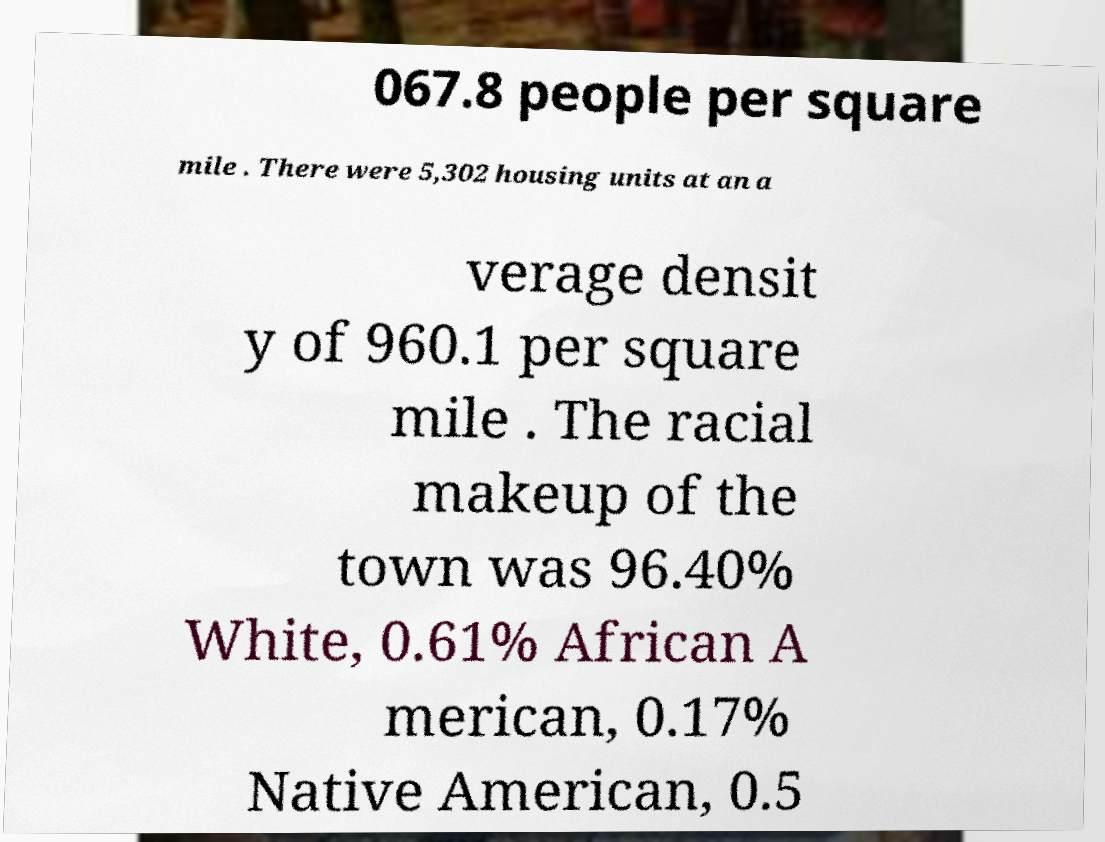There's text embedded in this image that I need extracted. Can you transcribe it verbatim? 067.8 people per square mile . There were 5,302 housing units at an a verage densit y of 960.1 per square mile . The racial makeup of the town was 96.40% White, 0.61% African A merican, 0.17% Native American, 0.5 